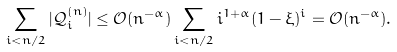<formula> <loc_0><loc_0><loc_500><loc_500>\sum _ { i < n / 2 } | \mathcal { Q } ^ { ( n ) } _ { i } | \leq { \mathcal { O } } ( n ^ { - \alpha } ) \sum _ { i < n / 2 } i ^ { 1 + \alpha } ( 1 - \xi ) ^ { i } = { \mathcal { O } } ( n ^ { - \alpha } ) .</formula> 